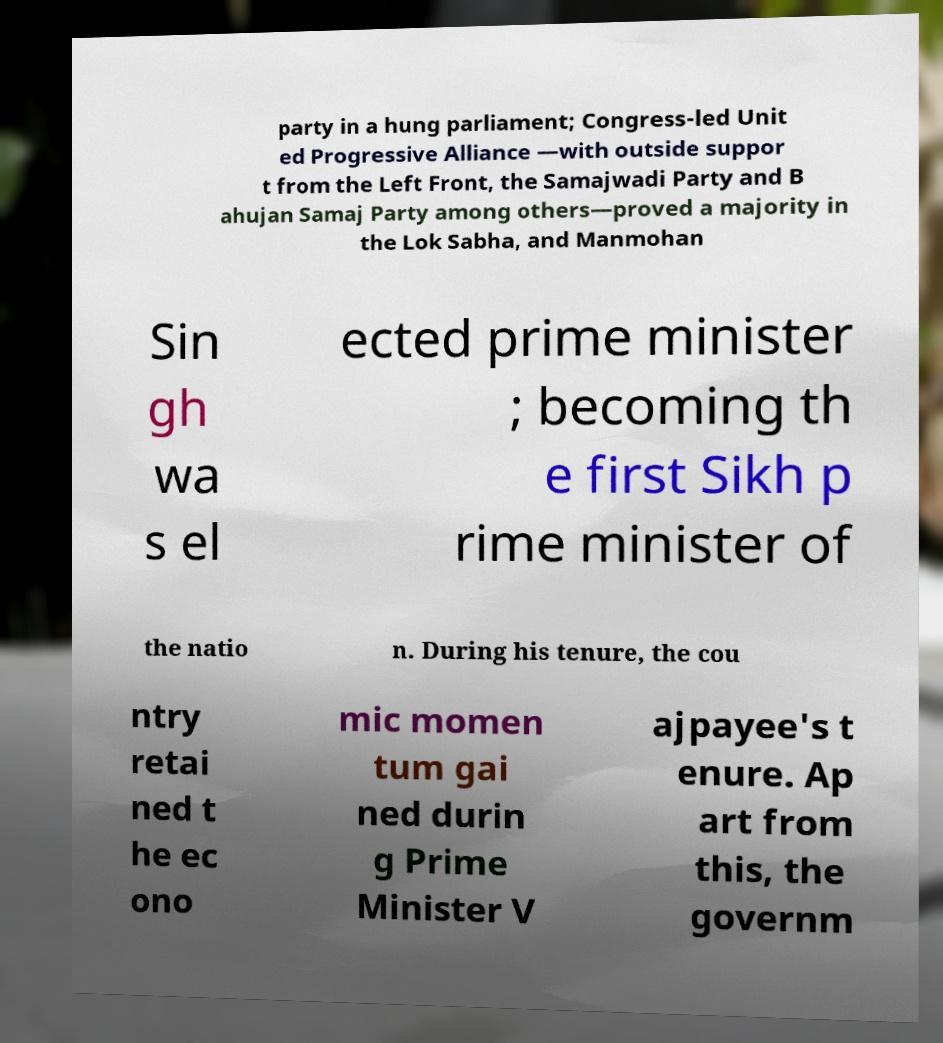Please identify and transcribe the text found in this image. party in a hung parliament; Congress-led Unit ed Progressive Alliance —with outside suppor t from the Left Front, the Samajwadi Party and B ahujan Samaj Party among others—proved a majority in the Lok Sabha, and Manmohan Sin gh wa s el ected prime minister ; becoming th e first Sikh p rime minister of the natio n. During his tenure, the cou ntry retai ned t he ec ono mic momen tum gai ned durin g Prime Minister V ajpayee's t enure. Ap art from this, the governm 